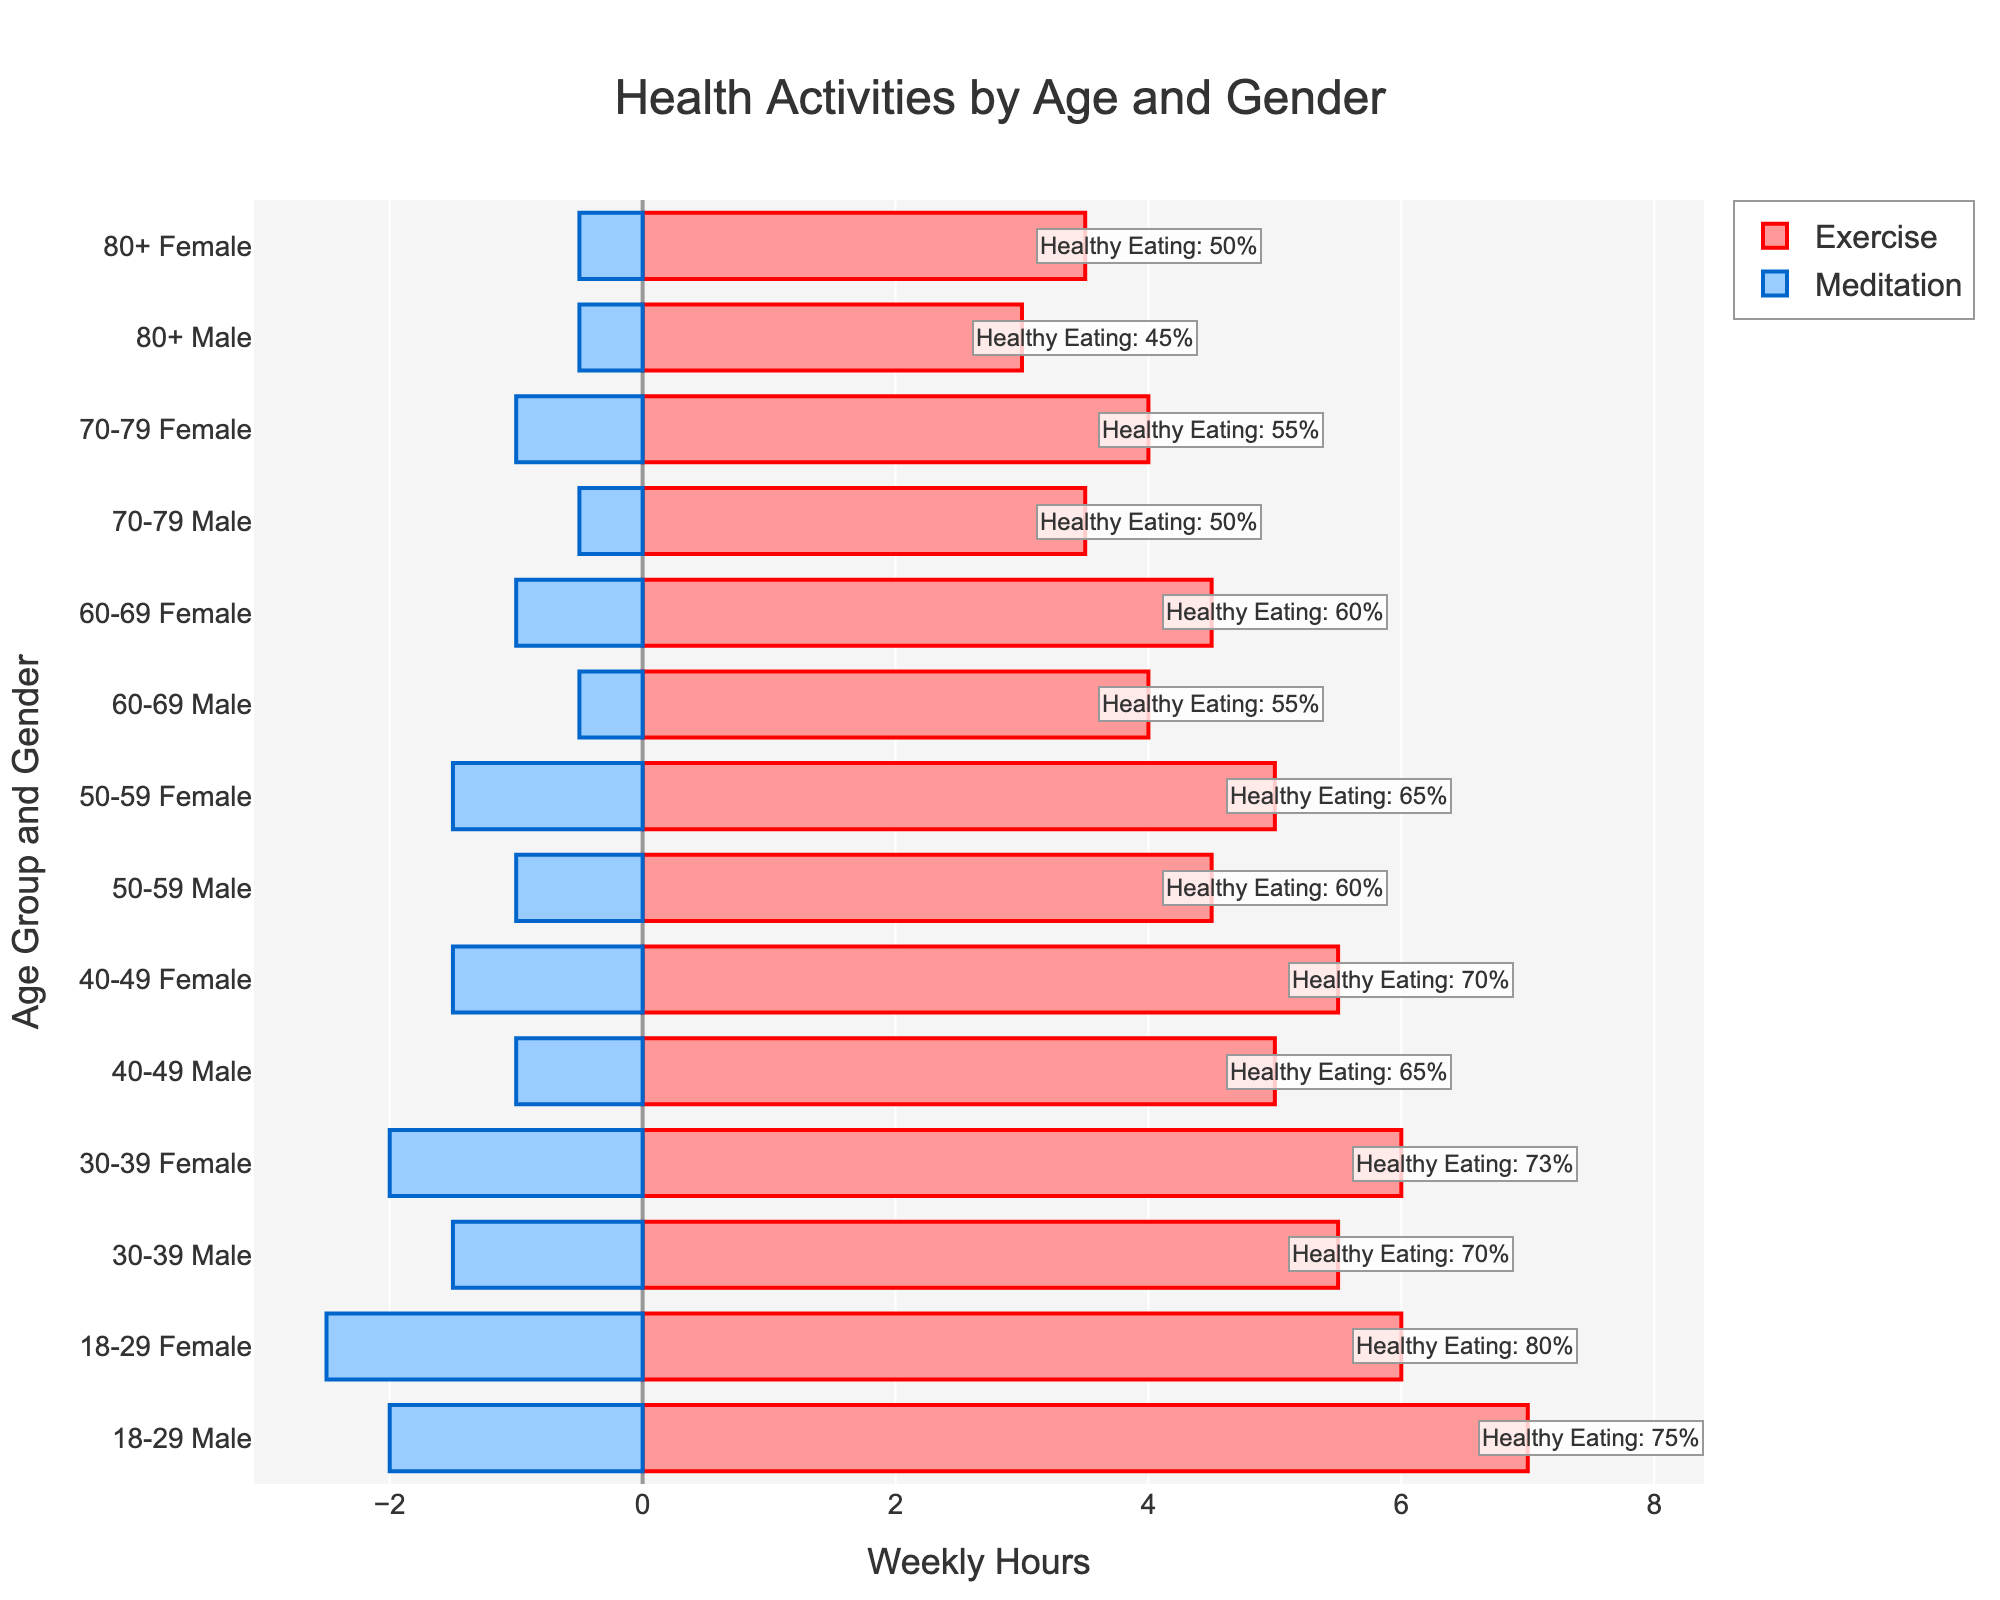What's the total weekly hours of exercise and meditation for the 30-39 age group females? From the figure, 30-39 age group females exercise 6 hours weekly and meditate 2 hours weekly. Summing them up gives 6 + 2 = 8 hours.
Answer: 8 hours Which age group and gender has the highest weekly exercise hours? By comparing the lengths of the Exercise bars for each Age_Gender group, 18-29 age group males have the highest weekly exercise hours with 7 hours.
Answer: 18-29 Male What is the difference in weekly exercise hours between 50-59 age group males and 60-69 age group males? The figure shows 50-59 age group males exercise 4.5 hours weekly while 60-69 age group males exercise 4 hours weekly. The difference is 4.5 - 4 = 0.5 hours.
Answer: 0.5 hours For the 40-49 age group, how does the weekly meditation time for males compare to females? The figure indicates that males have 1 hour of meditation weekly and females have 1.5 hours. 1.5 > 1, hence females meditate more.
Answer: Females meditate more Which group has the highest percentage of healthy eating? By referring to the annotations in the figure, the 18-29 age group females have the highest percentage of healthy eating with 80%.
Answer: 18-29 Female What is the combined weekly meditation and exercise hours for 80+ age group males? From the figure, 80+ age group males exercise 3 hours and meditate 0.5 hours weekly. Adding these gives 3 + 0.5 = 3.5 hours.
Answer: 3.5 hours Does any age group have equal weekly exercise and meditation hours? Observing the figure, in all cases, the exercise hours are greater than the meditation hours, so no age group has equal weekly exercise and meditation hours.
Answer: No How much more do 18-29 age group females exercise compared to 70-79 age group females? Referring to the figure, 18-29 age group females exercise 6 hours weekly, and 70-79 age group females exercise 4 hours weekly. The difference is 6 - 4 = 2 hours.
Answer: 2 hours What is the average weekly exercise hours for all males in their 40s and 50s? From the data, males in their 40s exercise 5 hours and males in their 50s exercise 4.5 hours weekly. The average is (5 + 4.5) / 2 = 4.75 hours.
Answer: 4.75 hours In terms of healthy eating, do females or males in the 60-69 age group have a higher percentage, and by how much? The figure shows females in the 60-69 age group have a healthy eating percentage of 60%, while males have 55%. The difference is 60 - 55 = 5%.
Answer: Females by 5% 